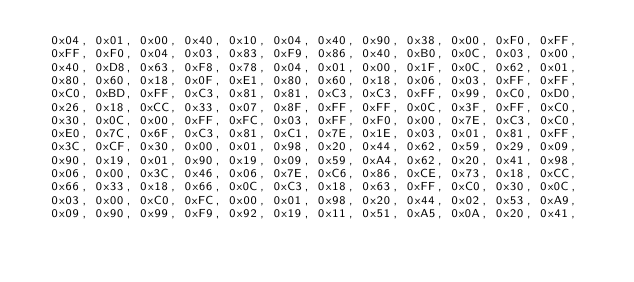<code> <loc_0><loc_0><loc_500><loc_500><_C_>  0x04, 0x01, 0x00, 0x40, 0x10, 0x04, 0x40, 0x90, 0x38, 0x00, 0xF0, 0xFF,
  0xFF, 0xF0, 0x04, 0x03, 0x83, 0xF9, 0x86, 0x40, 0xB0, 0x0C, 0x03, 0x00,
  0x40, 0xD8, 0x63, 0xF8, 0x78, 0x04, 0x01, 0x00, 0x1F, 0x0C, 0x62, 0x01,
  0x80, 0x60, 0x18, 0x0F, 0xE1, 0x80, 0x60, 0x18, 0x06, 0x03, 0xFF, 0xFF,
  0xC0, 0xBD, 0xFF, 0xC3, 0x81, 0x81, 0xC3, 0xC3, 0xFF, 0x99, 0xC0, 0xD0,
  0x26, 0x18, 0xCC, 0x33, 0x07, 0x8F, 0xFF, 0xFF, 0x0C, 0x3F, 0xFF, 0xC0,
  0x30, 0x0C, 0x00, 0xFF, 0xFC, 0x03, 0xFF, 0xF0, 0x00, 0x7E, 0xC3, 0xC0,
  0xE0, 0x7C, 0x6F, 0xC3, 0x81, 0xC1, 0x7E, 0x1E, 0x03, 0x01, 0x81, 0xFF,
  0x3C, 0xCF, 0x30, 0x00, 0x01, 0x98, 0x20, 0x44, 0x62, 0x59, 0x29, 0x09,
  0x90, 0x19, 0x01, 0x90, 0x19, 0x09, 0x59, 0xA4, 0x62, 0x20, 0x41, 0x98,
  0x06, 0x00, 0x3C, 0x46, 0x06, 0x7E, 0xC6, 0x86, 0xCE, 0x73, 0x18, 0xCC,
  0x66, 0x33, 0x18, 0x66, 0x0C, 0xC3, 0x18, 0x63, 0xFF, 0xC0, 0x30, 0x0C,
  0x03, 0x00, 0xC0, 0xFC, 0x00, 0x01, 0x98, 0x20, 0x44, 0x02, 0x53, 0xA9,
  0x09, 0x90, 0x99, 0xF9, 0x92, 0x19, 0x11, 0x51, 0xA5, 0x0A, 0x20, 0x41,</code> 